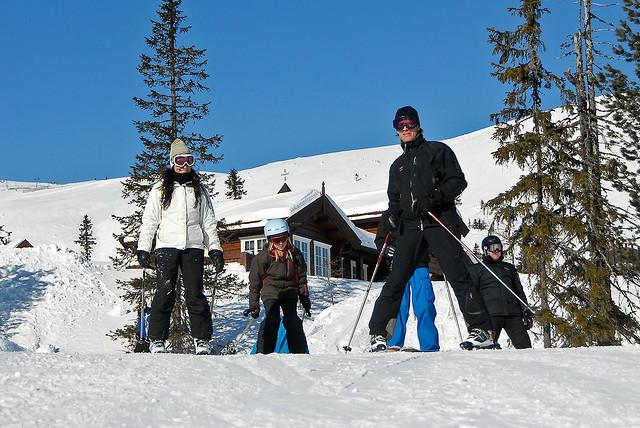Why are the children's heads covered?

Choices:
A) visibility
B) fashion
C) protection
D) religion protection 